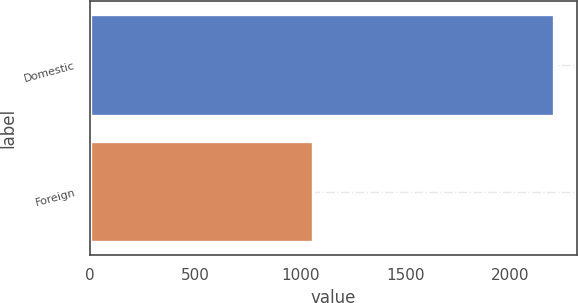<chart> <loc_0><loc_0><loc_500><loc_500><bar_chart><fcel>Domestic<fcel>Foreign<nl><fcel>2204<fcel>1061<nl></chart> 